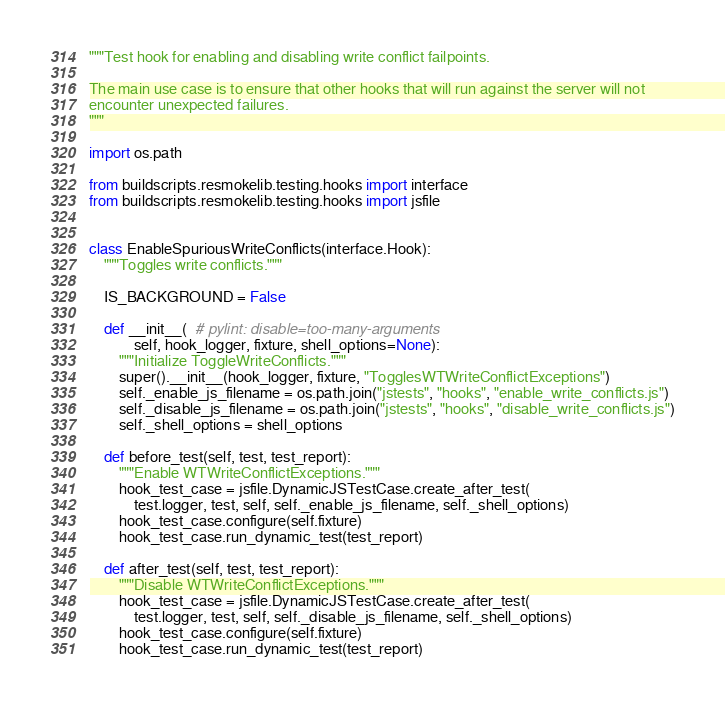<code> <loc_0><loc_0><loc_500><loc_500><_Python_>"""Test hook for enabling and disabling write conflict failpoints.

The main use case is to ensure that other hooks that will run against the server will not
encounter unexpected failures.
"""

import os.path

from buildscripts.resmokelib.testing.hooks import interface
from buildscripts.resmokelib.testing.hooks import jsfile


class EnableSpuriousWriteConflicts(interface.Hook):
    """Toggles write conflicts."""

    IS_BACKGROUND = False

    def __init__(  # pylint: disable=too-many-arguments
            self, hook_logger, fixture, shell_options=None):
        """Initialize ToggleWriteConflicts."""
        super().__init__(hook_logger, fixture, "TogglesWTWriteConflictExceptions")
        self._enable_js_filename = os.path.join("jstests", "hooks", "enable_write_conflicts.js")
        self._disable_js_filename = os.path.join("jstests", "hooks", "disable_write_conflicts.js")
        self._shell_options = shell_options

    def before_test(self, test, test_report):
        """Enable WTWriteConflictExceptions."""
        hook_test_case = jsfile.DynamicJSTestCase.create_after_test(
            test.logger, test, self, self._enable_js_filename, self._shell_options)
        hook_test_case.configure(self.fixture)
        hook_test_case.run_dynamic_test(test_report)

    def after_test(self, test, test_report):
        """Disable WTWriteConflictExceptions."""
        hook_test_case = jsfile.DynamicJSTestCase.create_after_test(
            test.logger, test, self, self._disable_js_filename, self._shell_options)
        hook_test_case.configure(self.fixture)
        hook_test_case.run_dynamic_test(test_report)
</code> 